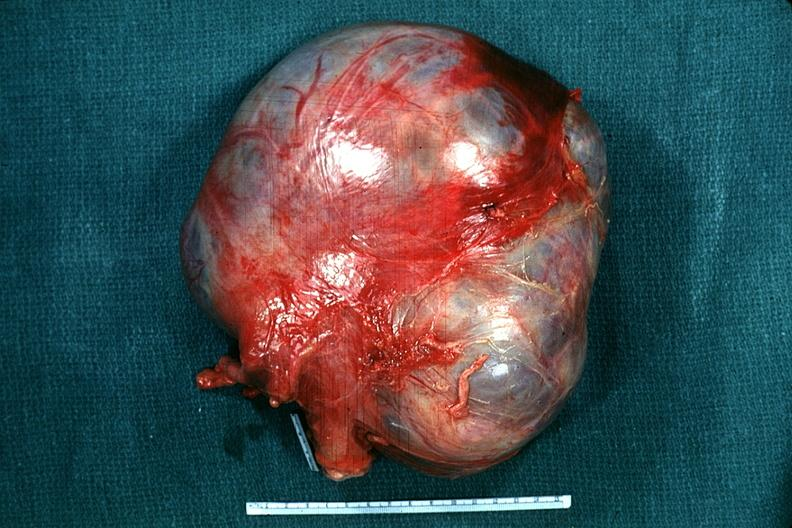does this image show external view typical appearance?
Answer the question using a single word or phrase. Yes 